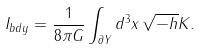<formula> <loc_0><loc_0><loc_500><loc_500>I _ { b d y } = \frac { 1 } { 8 \pi G } \int _ { \partial Y } d ^ { 3 } x \, \sqrt { - h } K .</formula> 